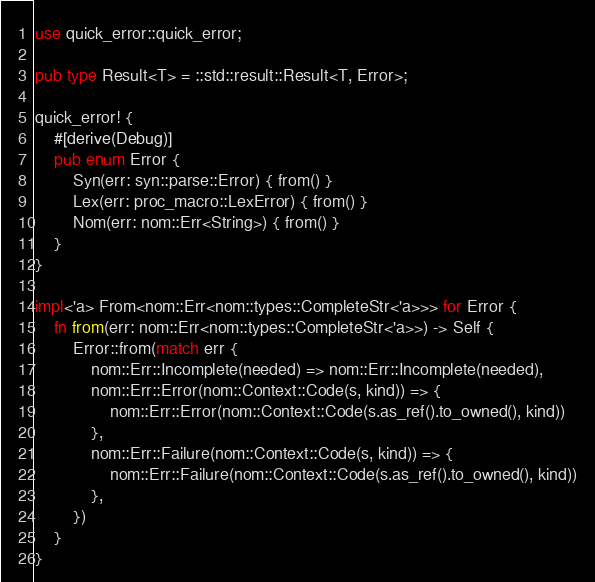<code> <loc_0><loc_0><loc_500><loc_500><_Rust_>use quick_error::quick_error;

pub type Result<T> = ::std::result::Result<T, Error>;

quick_error! {
    #[derive(Debug)]
    pub enum Error {
        Syn(err: syn::parse::Error) { from() }
        Lex(err: proc_macro::LexError) { from() }
        Nom(err: nom::Err<String>) { from() }
    }
}

impl<'a> From<nom::Err<nom::types::CompleteStr<'a>>> for Error {
    fn from(err: nom::Err<nom::types::CompleteStr<'a>>) -> Self {
        Error::from(match err {
            nom::Err::Incomplete(needed) => nom::Err::Incomplete(needed),
            nom::Err::Error(nom::Context::Code(s, kind)) => {
                nom::Err::Error(nom::Context::Code(s.as_ref().to_owned(), kind))
            },
            nom::Err::Failure(nom::Context::Code(s, kind)) => {
                nom::Err::Failure(nom::Context::Code(s.as_ref().to_owned(), kind))
            },
        })
    }
}
</code> 